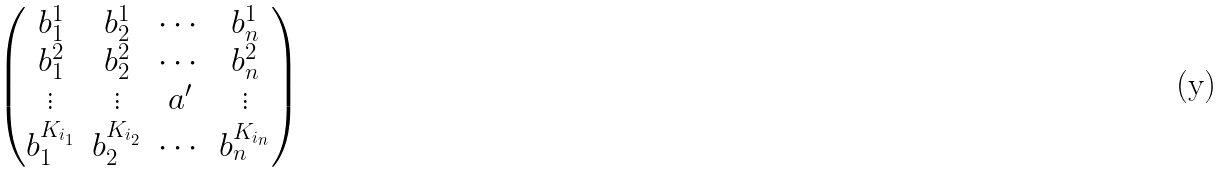Convert formula to latex. <formula><loc_0><loc_0><loc_500><loc_500>\begin{pmatrix} b _ { 1 } ^ { 1 } & b _ { 2 } ^ { 1 } & \cdots & b _ { n } ^ { 1 } \\ b _ { 1 } ^ { 2 } & b _ { 2 } ^ { 2 } & \cdots & b _ { n } ^ { 2 } \\ \vdots & \vdots & a ^ { \prime } & \vdots \\ b _ { 1 } ^ { K _ { i _ { 1 } } } & b _ { 2 } ^ { K _ { i _ { 2 } } } & \cdots & b _ { n } ^ { K _ { i _ { n } } } \end{pmatrix}</formula> 